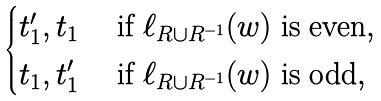Convert formula to latex. <formula><loc_0><loc_0><loc_500><loc_500>\begin{cases} t ^ { \prime } _ { 1 } , t _ { 1 } & \text { if } \ell _ { R \cup R ^ { - 1 } } ( w ) \text { is even} , \\ t _ { 1 } , t ^ { \prime } _ { 1 } & \text { if } \ell _ { R \cup R ^ { - 1 } } ( w ) \text { is odd} , \\ \end{cases}</formula> 